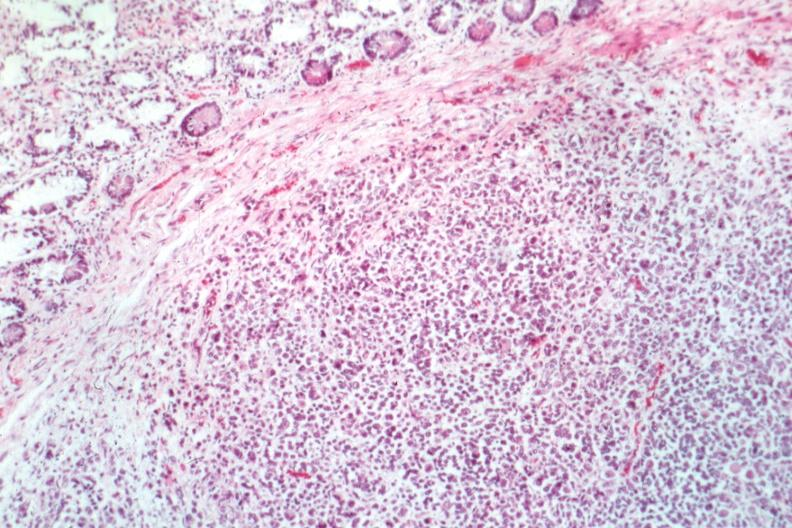does atrophy secondary to pituitectomy show good example can tell even at this what the tumor is?
Answer the question using a single word or phrase. No 